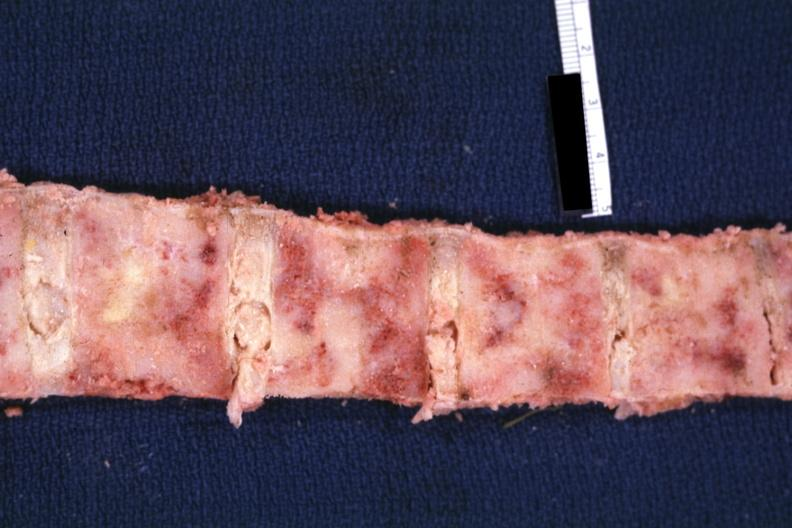s nodules present?
Answer the question using a single word or phrase. No 